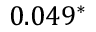Convert formula to latex. <formula><loc_0><loc_0><loc_500><loc_500>0 . 0 4 9 ^ { * }</formula> 